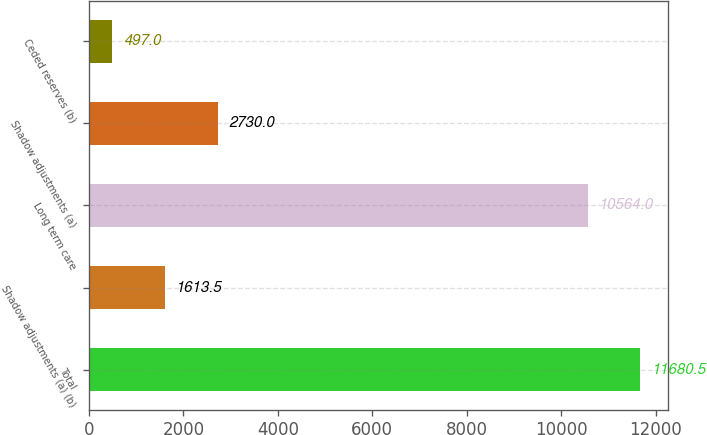<chart> <loc_0><loc_0><loc_500><loc_500><bar_chart><fcel>Total<fcel>Shadow adjustments (a) (b)<fcel>Long term care<fcel>Shadow adjustments (a)<fcel>Ceded reserves (b)<nl><fcel>11680.5<fcel>1613.5<fcel>10564<fcel>2730<fcel>497<nl></chart> 